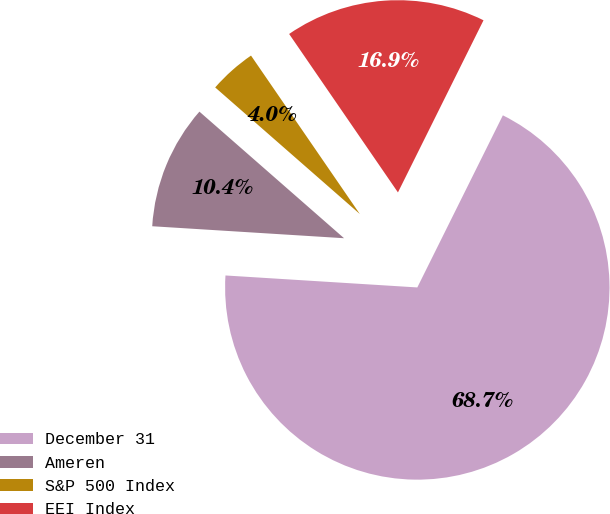Convert chart to OTSL. <chart><loc_0><loc_0><loc_500><loc_500><pie_chart><fcel>December 31<fcel>Ameren<fcel>S&P 500 Index<fcel>EEI Index<nl><fcel>68.65%<fcel>10.45%<fcel>3.98%<fcel>16.92%<nl></chart> 